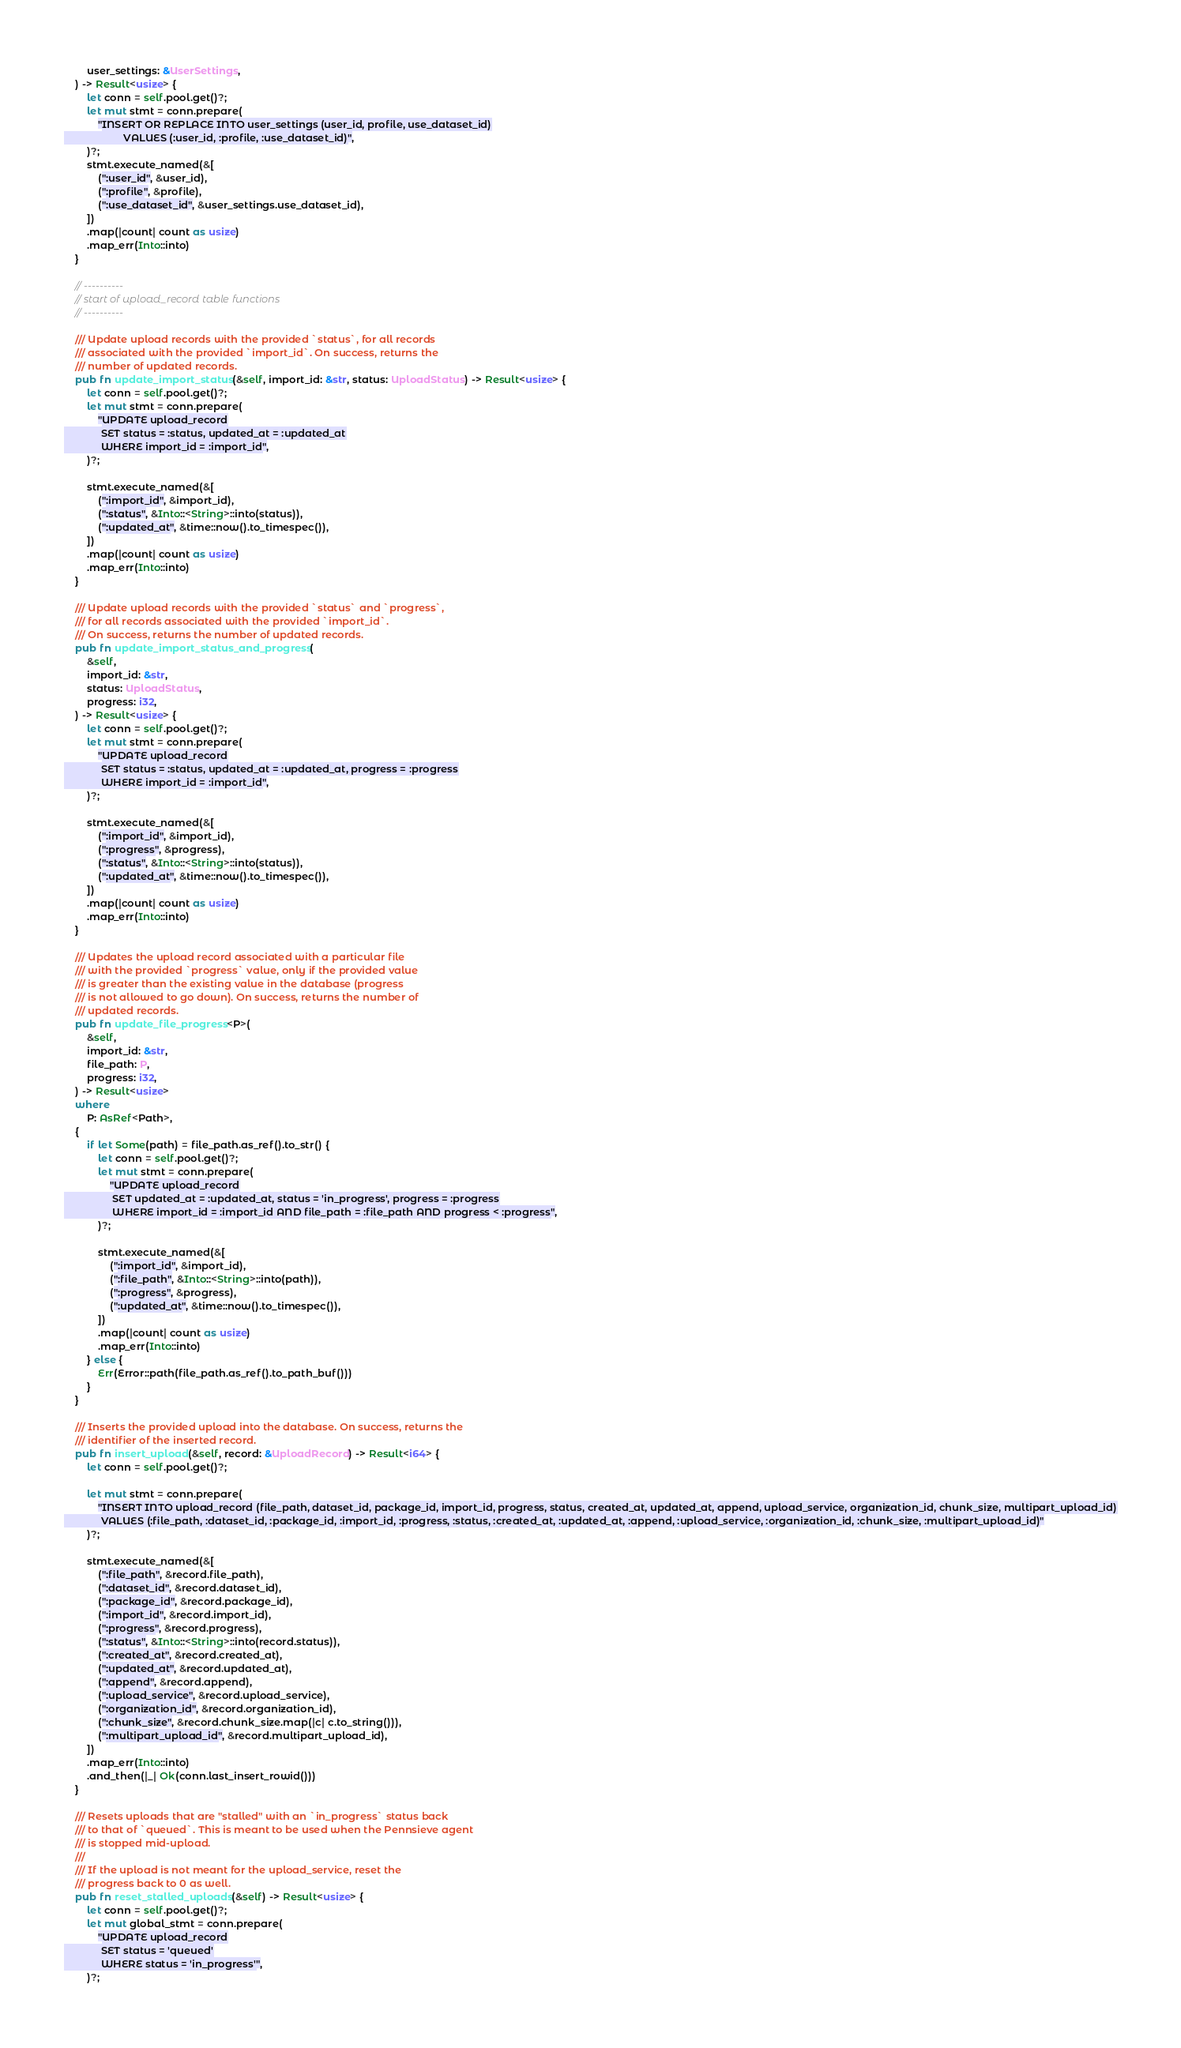<code> <loc_0><loc_0><loc_500><loc_500><_Rust_>        user_settings: &UserSettings,
    ) -> Result<usize> {
        let conn = self.pool.get()?;
        let mut stmt = conn.prepare(
            "INSERT OR REPLACE INTO user_settings (user_id, profile, use_dataset_id)
                     VALUES (:user_id, :profile, :use_dataset_id)",
        )?;
        stmt.execute_named(&[
            (":user_id", &user_id),
            (":profile", &profile),
            (":use_dataset_id", &user_settings.use_dataset_id),
        ])
        .map(|count| count as usize)
        .map_err(Into::into)
    }

    // ----------
    // start of upload_record table functions
    // ----------

    /// Update upload records with the provided `status`, for all records
    /// associated with the provided `import_id`. On success, returns the
    /// number of updated records.
    pub fn update_import_status(&self, import_id: &str, status: UploadStatus) -> Result<usize> {
        let conn = self.pool.get()?;
        let mut stmt = conn.prepare(
            "UPDATE upload_record
             SET status = :status, updated_at = :updated_at
             WHERE import_id = :import_id",
        )?;

        stmt.execute_named(&[
            (":import_id", &import_id),
            (":status", &Into::<String>::into(status)),
            (":updated_at", &time::now().to_timespec()),
        ])
        .map(|count| count as usize)
        .map_err(Into::into)
    }

    /// Update upload records with the provided `status` and `progress`,
    /// for all records associated with the provided `import_id`.
    /// On success, returns the number of updated records.
    pub fn update_import_status_and_progress(
        &self,
        import_id: &str,
        status: UploadStatus,
        progress: i32,
    ) -> Result<usize> {
        let conn = self.pool.get()?;
        let mut stmt = conn.prepare(
            "UPDATE upload_record
             SET status = :status, updated_at = :updated_at, progress = :progress
             WHERE import_id = :import_id",
        )?;

        stmt.execute_named(&[
            (":import_id", &import_id),
            (":progress", &progress),
            (":status", &Into::<String>::into(status)),
            (":updated_at", &time::now().to_timespec()),
        ])
        .map(|count| count as usize)
        .map_err(Into::into)
    }

    /// Updates the upload record associated with a particular file
    /// with the provided `progress` value, only if the provided value
    /// is greater than the existing value in the database (progress
    /// is not allowed to go down). On success, returns the number of
    /// updated records.
    pub fn update_file_progress<P>(
        &self,
        import_id: &str,
        file_path: P,
        progress: i32,
    ) -> Result<usize>
    where
        P: AsRef<Path>,
    {
        if let Some(path) = file_path.as_ref().to_str() {
            let conn = self.pool.get()?;
            let mut stmt = conn.prepare(
                "UPDATE upload_record
                 SET updated_at = :updated_at, status = 'in_progress', progress = :progress
                 WHERE import_id = :import_id AND file_path = :file_path AND progress < :progress",
            )?;

            stmt.execute_named(&[
                (":import_id", &import_id),
                (":file_path", &Into::<String>::into(path)),
                (":progress", &progress),
                (":updated_at", &time::now().to_timespec()),
            ])
            .map(|count| count as usize)
            .map_err(Into::into)
        } else {
            Err(Error::path(file_path.as_ref().to_path_buf()))
        }
    }

    /// Inserts the provided upload into the database. On success, returns the
    /// identifier of the inserted record.
    pub fn insert_upload(&self, record: &UploadRecord) -> Result<i64> {
        let conn = self.pool.get()?;

        let mut stmt = conn.prepare(
            "INSERT INTO upload_record (file_path, dataset_id, package_id, import_id, progress, status, created_at, updated_at, append, upload_service, organization_id, chunk_size, multipart_upload_id)
             VALUES (:file_path, :dataset_id, :package_id, :import_id, :progress, :status, :created_at, :updated_at, :append, :upload_service, :organization_id, :chunk_size, :multipart_upload_id)"
        )?;

        stmt.execute_named(&[
            (":file_path", &record.file_path),
            (":dataset_id", &record.dataset_id),
            (":package_id", &record.package_id),
            (":import_id", &record.import_id),
            (":progress", &record.progress),
            (":status", &Into::<String>::into(record.status)),
            (":created_at", &record.created_at),
            (":updated_at", &record.updated_at),
            (":append", &record.append),
            (":upload_service", &record.upload_service),
            (":organization_id", &record.organization_id),
            (":chunk_size", &record.chunk_size.map(|c| c.to_string())),
            (":multipart_upload_id", &record.multipart_upload_id),
        ])
        .map_err(Into::into)
        .and_then(|_| Ok(conn.last_insert_rowid()))
    }

    /// Resets uploads that are "stalled" with an `in_progress` status back
    /// to that of `queued`. This is meant to be used when the Pennsieve agent
    /// is stopped mid-upload.
    ///
    /// If the upload is not meant for the upload_service, reset the
    /// progress back to 0 as well.
    pub fn reset_stalled_uploads(&self) -> Result<usize> {
        let conn = self.pool.get()?;
        let mut global_stmt = conn.prepare(
            "UPDATE upload_record
             SET status = 'queued'
             WHERE status = 'in_progress'",
        )?;</code> 